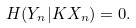Convert formula to latex. <formula><loc_0><loc_0><loc_500><loc_500>H ( Y _ { n } | K X _ { n } ) = 0 .</formula> 